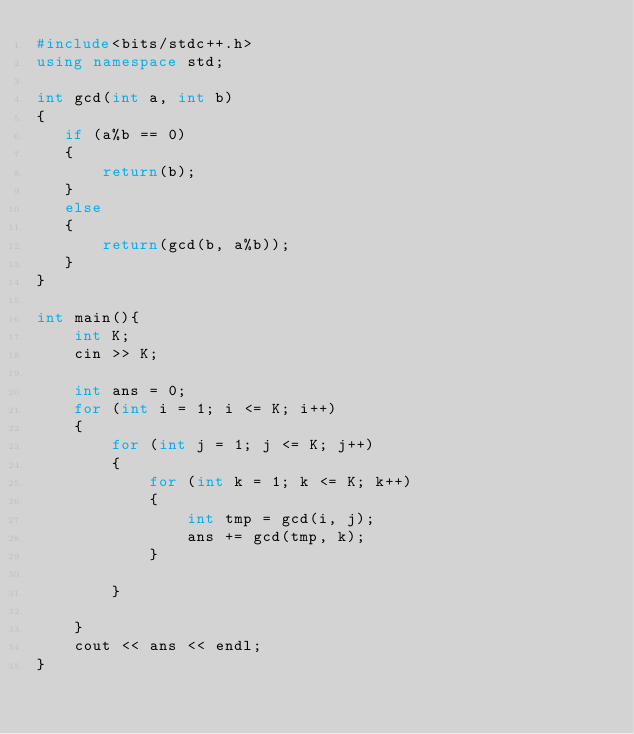<code> <loc_0><loc_0><loc_500><loc_500><_C++_>#include<bits/stdc++.h>
using namespace std;

int gcd(int a, int b)
{
   if (a%b == 0)
   {
       return(b);
   }
   else
   {
       return(gcd(b, a%b));
   }
}

int main(){
    int K;
    cin >> K;

    int ans = 0;
    for (int i = 1; i <= K; i++)
    {
        for (int j = 1; j <= K; j++)
        {
            for (int k = 1; k <= K; k++)
            {
                int tmp = gcd(i, j);
                ans += gcd(tmp, k);
            }
            
        }
        
    }
    cout << ans << endl;
}</code> 